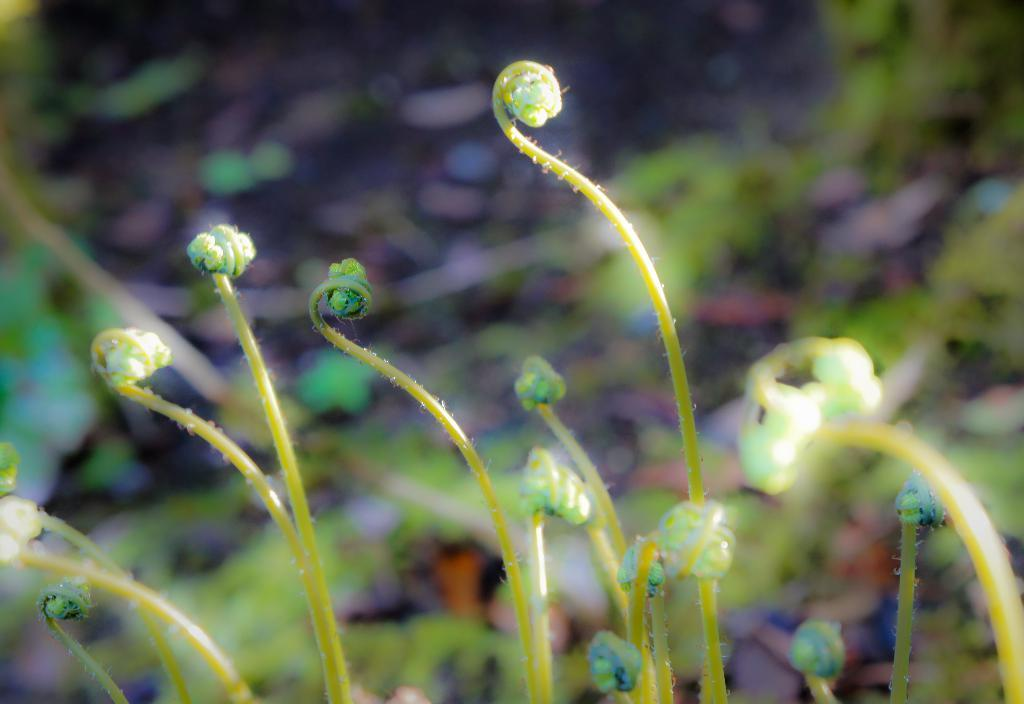What type of living organisms can be seen in the image? Plants can be seen in the image. Can you describe the background of the image? The background of the image is blurred. What type of glue is being used to hold the plants together in the image? There is no glue present in the image, and the plants are not being held together. 